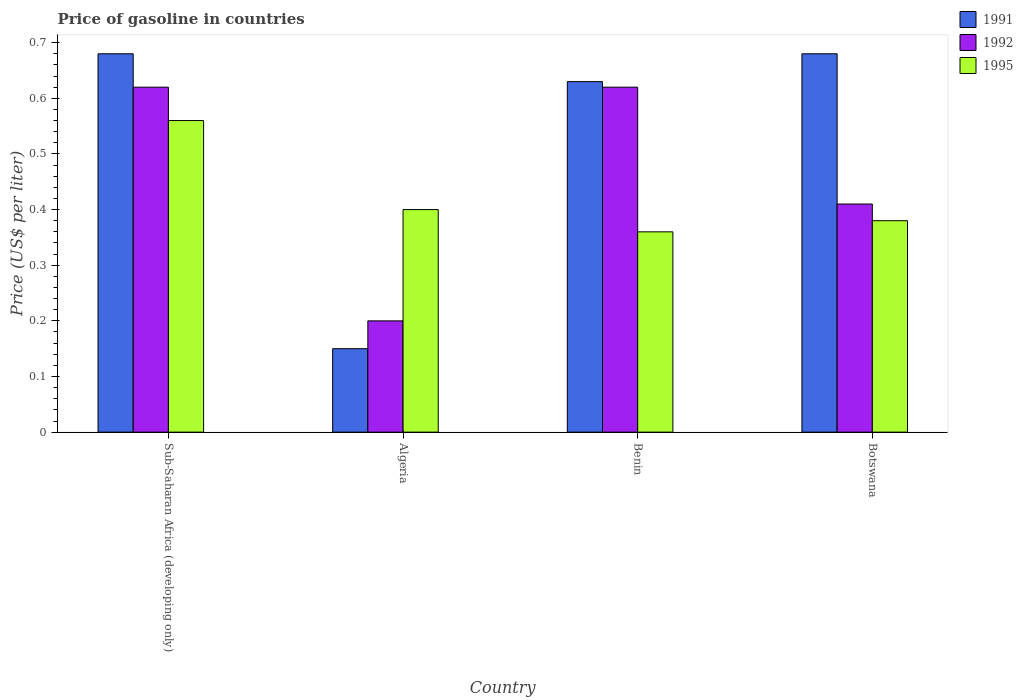How many different coloured bars are there?
Ensure brevity in your answer.  3. Are the number of bars per tick equal to the number of legend labels?
Provide a succinct answer. Yes. Are the number of bars on each tick of the X-axis equal?
Your response must be concise. Yes. How many bars are there on the 2nd tick from the left?
Provide a succinct answer. 3. How many bars are there on the 4th tick from the right?
Your answer should be compact. 3. What is the label of the 4th group of bars from the left?
Ensure brevity in your answer.  Botswana. What is the price of gasoline in 1991 in Sub-Saharan Africa (developing only)?
Ensure brevity in your answer.  0.68. Across all countries, what is the maximum price of gasoline in 1992?
Provide a succinct answer. 0.62. Across all countries, what is the minimum price of gasoline in 1995?
Make the answer very short. 0.36. In which country was the price of gasoline in 1995 maximum?
Keep it short and to the point. Sub-Saharan Africa (developing only). In which country was the price of gasoline in 1995 minimum?
Your answer should be compact. Benin. What is the total price of gasoline in 1995 in the graph?
Offer a terse response. 1.7. What is the difference between the price of gasoline in 1992 in Algeria and that in Botswana?
Your answer should be very brief. -0.21. What is the difference between the price of gasoline in 1991 in Benin and the price of gasoline in 1995 in Sub-Saharan Africa (developing only)?
Your answer should be compact. 0.07. What is the average price of gasoline in 1995 per country?
Ensure brevity in your answer.  0.43. What is the difference between the price of gasoline of/in 1995 and price of gasoline of/in 1992 in Botswana?
Your response must be concise. -0.03. What is the ratio of the price of gasoline in 1992 in Algeria to that in Sub-Saharan Africa (developing only)?
Give a very brief answer. 0.32. What is the difference between the highest and the second highest price of gasoline in 1995?
Offer a very short reply. 0.16. What is the difference between the highest and the lowest price of gasoline in 1992?
Your response must be concise. 0.42. In how many countries, is the price of gasoline in 1995 greater than the average price of gasoline in 1995 taken over all countries?
Your answer should be very brief. 1. Is the sum of the price of gasoline in 1992 in Benin and Botswana greater than the maximum price of gasoline in 1991 across all countries?
Your answer should be compact. Yes. What does the 2nd bar from the left in Benin represents?
Offer a very short reply. 1992. What does the 2nd bar from the right in Benin represents?
Your response must be concise. 1992. How many bars are there?
Offer a terse response. 12. Are all the bars in the graph horizontal?
Keep it short and to the point. No. How many countries are there in the graph?
Provide a short and direct response. 4. What is the difference between two consecutive major ticks on the Y-axis?
Make the answer very short. 0.1. Does the graph contain any zero values?
Make the answer very short. No. Where does the legend appear in the graph?
Keep it short and to the point. Top right. What is the title of the graph?
Provide a short and direct response. Price of gasoline in countries. Does "2002" appear as one of the legend labels in the graph?
Offer a very short reply. No. What is the label or title of the Y-axis?
Give a very brief answer. Price (US$ per liter). What is the Price (US$ per liter) in 1991 in Sub-Saharan Africa (developing only)?
Your answer should be compact. 0.68. What is the Price (US$ per liter) of 1992 in Sub-Saharan Africa (developing only)?
Ensure brevity in your answer.  0.62. What is the Price (US$ per liter) of 1995 in Sub-Saharan Africa (developing only)?
Offer a terse response. 0.56. What is the Price (US$ per liter) of 1991 in Algeria?
Provide a short and direct response. 0.15. What is the Price (US$ per liter) of 1991 in Benin?
Provide a short and direct response. 0.63. What is the Price (US$ per liter) in 1992 in Benin?
Your answer should be very brief. 0.62. What is the Price (US$ per liter) in 1995 in Benin?
Ensure brevity in your answer.  0.36. What is the Price (US$ per liter) in 1991 in Botswana?
Make the answer very short. 0.68. What is the Price (US$ per liter) of 1992 in Botswana?
Your answer should be compact. 0.41. What is the Price (US$ per liter) in 1995 in Botswana?
Offer a terse response. 0.38. Across all countries, what is the maximum Price (US$ per liter) in 1991?
Your answer should be very brief. 0.68. Across all countries, what is the maximum Price (US$ per liter) in 1992?
Keep it short and to the point. 0.62. Across all countries, what is the maximum Price (US$ per liter) in 1995?
Provide a succinct answer. 0.56. Across all countries, what is the minimum Price (US$ per liter) of 1992?
Offer a very short reply. 0.2. Across all countries, what is the minimum Price (US$ per liter) in 1995?
Make the answer very short. 0.36. What is the total Price (US$ per liter) in 1991 in the graph?
Provide a succinct answer. 2.14. What is the total Price (US$ per liter) of 1992 in the graph?
Your answer should be compact. 1.85. What is the total Price (US$ per liter) in 1995 in the graph?
Provide a short and direct response. 1.7. What is the difference between the Price (US$ per liter) of 1991 in Sub-Saharan Africa (developing only) and that in Algeria?
Provide a succinct answer. 0.53. What is the difference between the Price (US$ per liter) of 1992 in Sub-Saharan Africa (developing only) and that in Algeria?
Ensure brevity in your answer.  0.42. What is the difference between the Price (US$ per liter) in 1995 in Sub-Saharan Africa (developing only) and that in Algeria?
Your response must be concise. 0.16. What is the difference between the Price (US$ per liter) of 1992 in Sub-Saharan Africa (developing only) and that in Benin?
Ensure brevity in your answer.  0. What is the difference between the Price (US$ per liter) in 1991 in Sub-Saharan Africa (developing only) and that in Botswana?
Your answer should be very brief. 0. What is the difference between the Price (US$ per liter) in 1992 in Sub-Saharan Africa (developing only) and that in Botswana?
Offer a terse response. 0.21. What is the difference between the Price (US$ per liter) of 1995 in Sub-Saharan Africa (developing only) and that in Botswana?
Provide a short and direct response. 0.18. What is the difference between the Price (US$ per liter) of 1991 in Algeria and that in Benin?
Ensure brevity in your answer.  -0.48. What is the difference between the Price (US$ per liter) of 1992 in Algeria and that in Benin?
Keep it short and to the point. -0.42. What is the difference between the Price (US$ per liter) in 1995 in Algeria and that in Benin?
Make the answer very short. 0.04. What is the difference between the Price (US$ per liter) of 1991 in Algeria and that in Botswana?
Offer a terse response. -0.53. What is the difference between the Price (US$ per liter) in 1992 in Algeria and that in Botswana?
Provide a succinct answer. -0.21. What is the difference between the Price (US$ per liter) of 1995 in Algeria and that in Botswana?
Your response must be concise. 0.02. What is the difference between the Price (US$ per liter) of 1992 in Benin and that in Botswana?
Your answer should be very brief. 0.21. What is the difference between the Price (US$ per liter) of 1995 in Benin and that in Botswana?
Make the answer very short. -0.02. What is the difference between the Price (US$ per liter) of 1991 in Sub-Saharan Africa (developing only) and the Price (US$ per liter) of 1992 in Algeria?
Provide a short and direct response. 0.48. What is the difference between the Price (US$ per liter) in 1991 in Sub-Saharan Africa (developing only) and the Price (US$ per liter) in 1995 in Algeria?
Provide a succinct answer. 0.28. What is the difference between the Price (US$ per liter) of 1992 in Sub-Saharan Africa (developing only) and the Price (US$ per liter) of 1995 in Algeria?
Provide a succinct answer. 0.22. What is the difference between the Price (US$ per liter) of 1991 in Sub-Saharan Africa (developing only) and the Price (US$ per liter) of 1992 in Benin?
Give a very brief answer. 0.06. What is the difference between the Price (US$ per liter) in 1991 in Sub-Saharan Africa (developing only) and the Price (US$ per liter) in 1995 in Benin?
Offer a terse response. 0.32. What is the difference between the Price (US$ per liter) in 1992 in Sub-Saharan Africa (developing only) and the Price (US$ per liter) in 1995 in Benin?
Provide a short and direct response. 0.26. What is the difference between the Price (US$ per liter) of 1991 in Sub-Saharan Africa (developing only) and the Price (US$ per liter) of 1992 in Botswana?
Your answer should be compact. 0.27. What is the difference between the Price (US$ per liter) in 1991 in Sub-Saharan Africa (developing only) and the Price (US$ per liter) in 1995 in Botswana?
Provide a succinct answer. 0.3. What is the difference between the Price (US$ per liter) of 1992 in Sub-Saharan Africa (developing only) and the Price (US$ per liter) of 1995 in Botswana?
Provide a succinct answer. 0.24. What is the difference between the Price (US$ per liter) in 1991 in Algeria and the Price (US$ per liter) in 1992 in Benin?
Keep it short and to the point. -0.47. What is the difference between the Price (US$ per liter) of 1991 in Algeria and the Price (US$ per liter) of 1995 in Benin?
Offer a very short reply. -0.21. What is the difference between the Price (US$ per liter) of 1992 in Algeria and the Price (US$ per liter) of 1995 in Benin?
Your answer should be very brief. -0.16. What is the difference between the Price (US$ per liter) in 1991 in Algeria and the Price (US$ per liter) in 1992 in Botswana?
Make the answer very short. -0.26. What is the difference between the Price (US$ per liter) in 1991 in Algeria and the Price (US$ per liter) in 1995 in Botswana?
Ensure brevity in your answer.  -0.23. What is the difference between the Price (US$ per liter) of 1992 in Algeria and the Price (US$ per liter) of 1995 in Botswana?
Offer a terse response. -0.18. What is the difference between the Price (US$ per liter) of 1991 in Benin and the Price (US$ per liter) of 1992 in Botswana?
Provide a short and direct response. 0.22. What is the difference between the Price (US$ per liter) of 1992 in Benin and the Price (US$ per liter) of 1995 in Botswana?
Your answer should be compact. 0.24. What is the average Price (US$ per liter) of 1991 per country?
Make the answer very short. 0.54. What is the average Price (US$ per liter) of 1992 per country?
Ensure brevity in your answer.  0.46. What is the average Price (US$ per liter) of 1995 per country?
Provide a succinct answer. 0.42. What is the difference between the Price (US$ per liter) in 1991 and Price (US$ per liter) in 1995 in Sub-Saharan Africa (developing only)?
Give a very brief answer. 0.12. What is the difference between the Price (US$ per liter) of 1992 and Price (US$ per liter) of 1995 in Sub-Saharan Africa (developing only)?
Provide a short and direct response. 0.06. What is the difference between the Price (US$ per liter) in 1991 and Price (US$ per liter) in 1992 in Algeria?
Make the answer very short. -0.05. What is the difference between the Price (US$ per liter) of 1991 and Price (US$ per liter) of 1995 in Algeria?
Your answer should be very brief. -0.25. What is the difference between the Price (US$ per liter) in 1991 and Price (US$ per liter) in 1992 in Benin?
Offer a terse response. 0.01. What is the difference between the Price (US$ per liter) of 1991 and Price (US$ per liter) of 1995 in Benin?
Provide a short and direct response. 0.27. What is the difference between the Price (US$ per liter) of 1992 and Price (US$ per liter) of 1995 in Benin?
Offer a terse response. 0.26. What is the difference between the Price (US$ per liter) in 1991 and Price (US$ per liter) in 1992 in Botswana?
Keep it short and to the point. 0.27. What is the difference between the Price (US$ per liter) in 1992 and Price (US$ per liter) in 1995 in Botswana?
Give a very brief answer. 0.03. What is the ratio of the Price (US$ per liter) in 1991 in Sub-Saharan Africa (developing only) to that in Algeria?
Offer a very short reply. 4.53. What is the ratio of the Price (US$ per liter) in 1992 in Sub-Saharan Africa (developing only) to that in Algeria?
Ensure brevity in your answer.  3.1. What is the ratio of the Price (US$ per liter) in 1991 in Sub-Saharan Africa (developing only) to that in Benin?
Provide a short and direct response. 1.08. What is the ratio of the Price (US$ per liter) of 1995 in Sub-Saharan Africa (developing only) to that in Benin?
Provide a short and direct response. 1.56. What is the ratio of the Price (US$ per liter) in 1992 in Sub-Saharan Africa (developing only) to that in Botswana?
Provide a succinct answer. 1.51. What is the ratio of the Price (US$ per liter) in 1995 in Sub-Saharan Africa (developing only) to that in Botswana?
Make the answer very short. 1.47. What is the ratio of the Price (US$ per liter) in 1991 in Algeria to that in Benin?
Provide a succinct answer. 0.24. What is the ratio of the Price (US$ per liter) in 1992 in Algeria to that in Benin?
Give a very brief answer. 0.32. What is the ratio of the Price (US$ per liter) of 1991 in Algeria to that in Botswana?
Make the answer very short. 0.22. What is the ratio of the Price (US$ per liter) of 1992 in Algeria to that in Botswana?
Provide a succinct answer. 0.49. What is the ratio of the Price (US$ per liter) in 1995 in Algeria to that in Botswana?
Provide a short and direct response. 1.05. What is the ratio of the Price (US$ per liter) in 1991 in Benin to that in Botswana?
Give a very brief answer. 0.93. What is the ratio of the Price (US$ per liter) in 1992 in Benin to that in Botswana?
Provide a short and direct response. 1.51. What is the difference between the highest and the second highest Price (US$ per liter) of 1991?
Offer a very short reply. 0. What is the difference between the highest and the second highest Price (US$ per liter) in 1992?
Your answer should be compact. 0. What is the difference between the highest and the second highest Price (US$ per liter) of 1995?
Your answer should be very brief. 0.16. What is the difference between the highest and the lowest Price (US$ per liter) of 1991?
Make the answer very short. 0.53. What is the difference between the highest and the lowest Price (US$ per liter) in 1992?
Your answer should be compact. 0.42. 